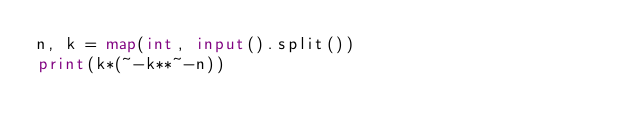Convert code to text. <code><loc_0><loc_0><loc_500><loc_500><_Python_>n, k = map(int, input().split())
print(k*(~-k**~-n))</code> 